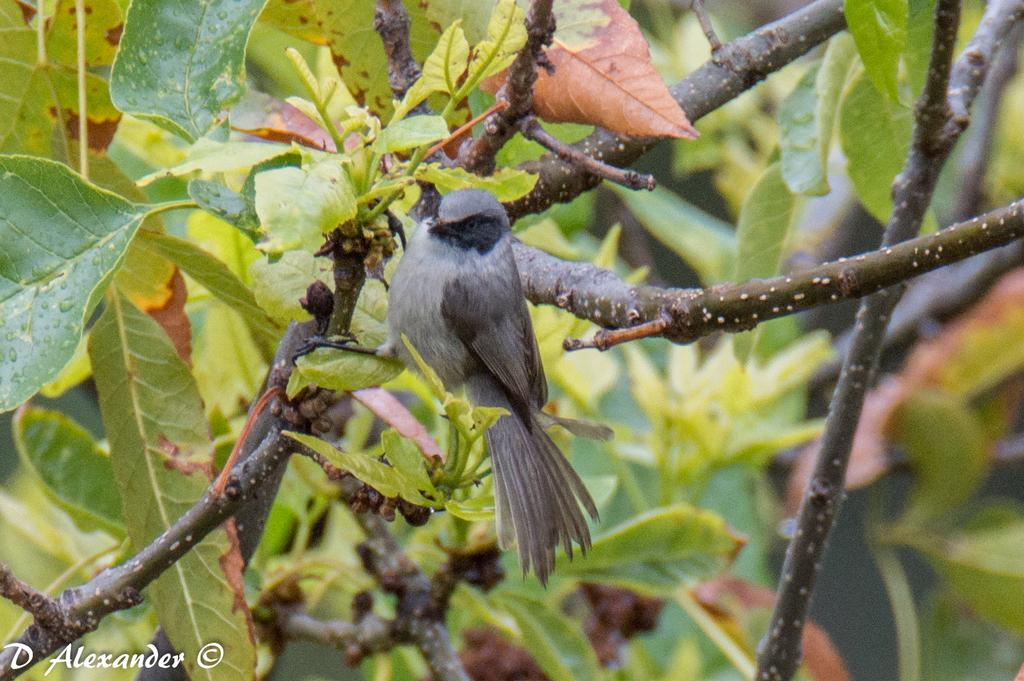What type of animal can be seen in the image? There is a bird in the image. Where is the bird located in the image? The bird is sitting on a stick. What type of vegetation is present in the image? There are green leaves in the image. What type of sugar is being used to sweeten the bird's lunch in the image? There is no lunch or sugar present in the image; it simply features a bird sitting on a stick with green leaves in the leaves in the background. 